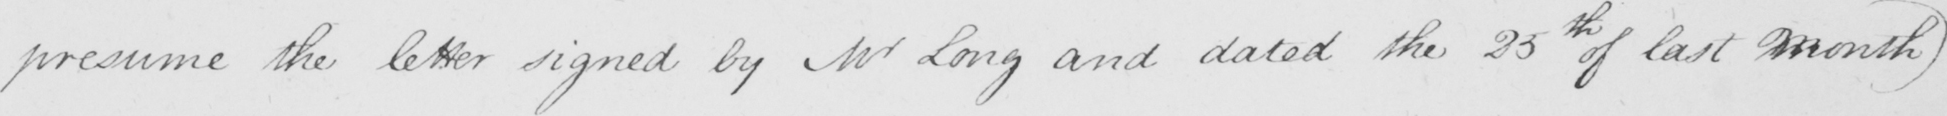What text is written in this handwritten line? presume the letter signed by Mr Long and dated the 25th of last Month ) 